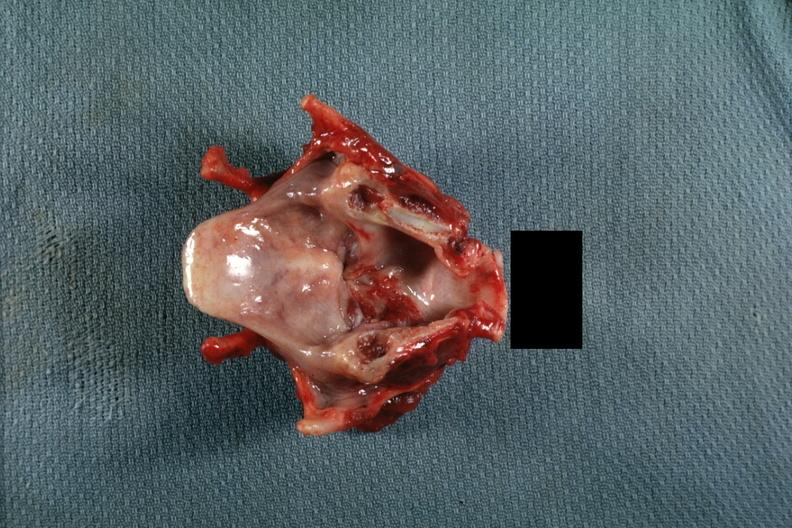what is present?
Answer the question using a single word or phrase. Larynx 